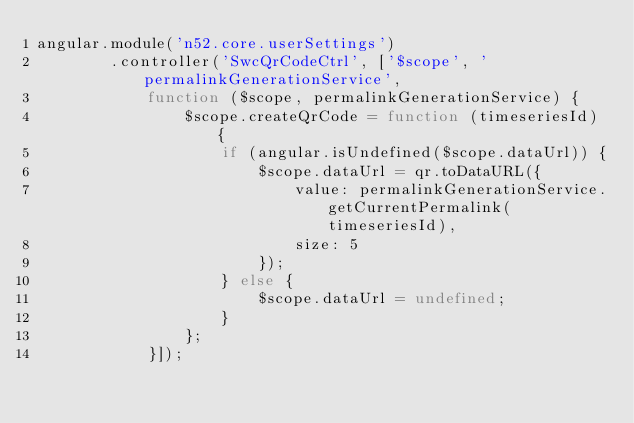<code> <loc_0><loc_0><loc_500><loc_500><_JavaScript_>angular.module('n52.core.userSettings')
        .controller('SwcQrCodeCtrl', ['$scope', 'permalinkGenerationService',
            function ($scope, permalinkGenerationService) {
                $scope.createQrCode = function (timeseriesId) {
                    if (angular.isUndefined($scope.dataUrl)) {
                        $scope.dataUrl = qr.toDataURL({
                            value: permalinkGenerationService.getCurrentPermalink(timeseriesId),
                            size: 5
                        });
                    } else {
                        $scope.dataUrl = undefined;
                    }
                };
            }]);</code> 